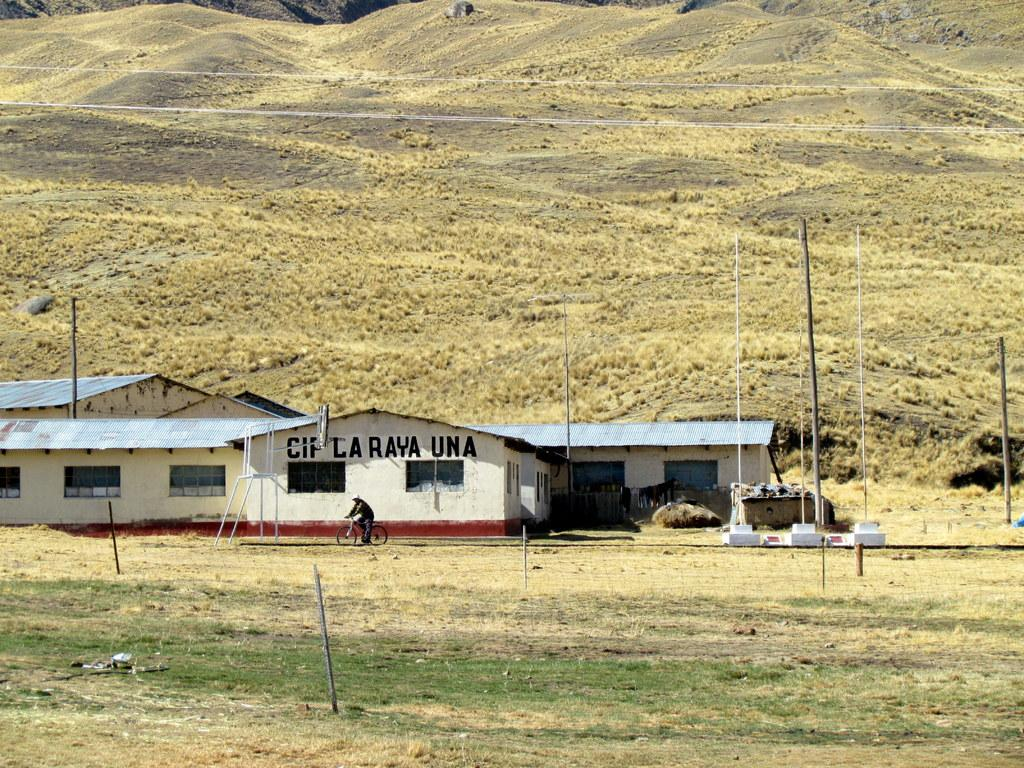What type of structures are located on the grassland in the image? There are godowns on the grassland in the image. What can be seen on either side of the godowns? There are poles on either side of the godowns. What is the man in the image doing? A man is riding a bicycle in front of the godowns. What can be seen in the distance behind the godowns? There are hills visible in the background. What type of screw is being used to hold the can in the image? There is no can or screw present in the image. Are there any police officers visible in the image? There are no police officers visible in the image. 